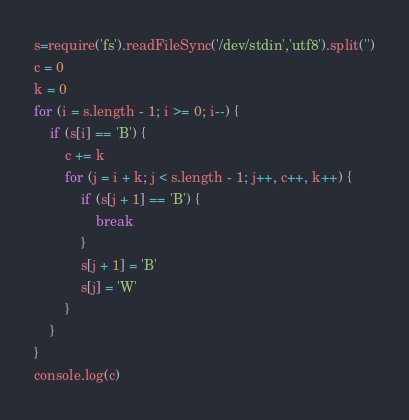<code> <loc_0><loc_0><loc_500><loc_500><_TypeScript_>s=require('fs').readFileSync('/dev/stdin','utf8').split('')
c = 0
k = 0
for (i = s.length - 1; i >= 0; i--) {
	if (s[i] == 'B') {
		c += k
		for (j = i + k; j < s.length - 1; j++, c++, k++) {
			if (s[j + 1] == 'B') {
				break
			}
			s[j + 1] = 'B'
			s[j] = 'W'
		}
	}
}
console.log(c)
</code> 